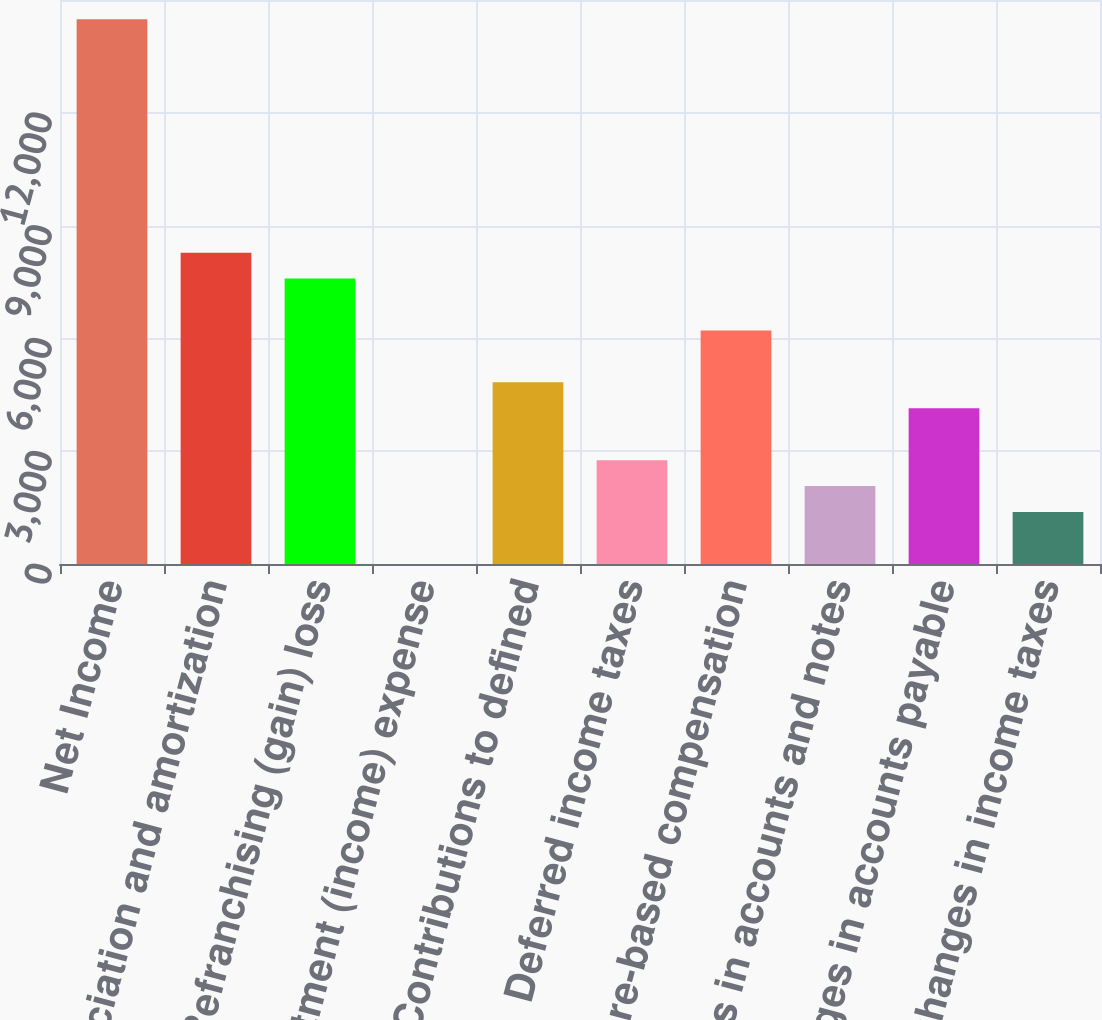Convert chart. <chart><loc_0><loc_0><loc_500><loc_500><bar_chart><fcel>Net Income<fcel>Depreciation and amortization<fcel>Refranchising (gain) loss<fcel>Investment (income) expense<fcel>Contributions to defined<fcel>Deferred income taxes<fcel>Share-based compensation<fcel>Changes in accounts and notes<fcel>Changes in accounts payable<fcel>Changes in income taxes<nl><fcel>14487.8<fcel>8279.6<fcel>7589.8<fcel>2<fcel>4830.6<fcel>2761.2<fcel>6210.2<fcel>2071.4<fcel>4140.8<fcel>1381.6<nl></chart> 